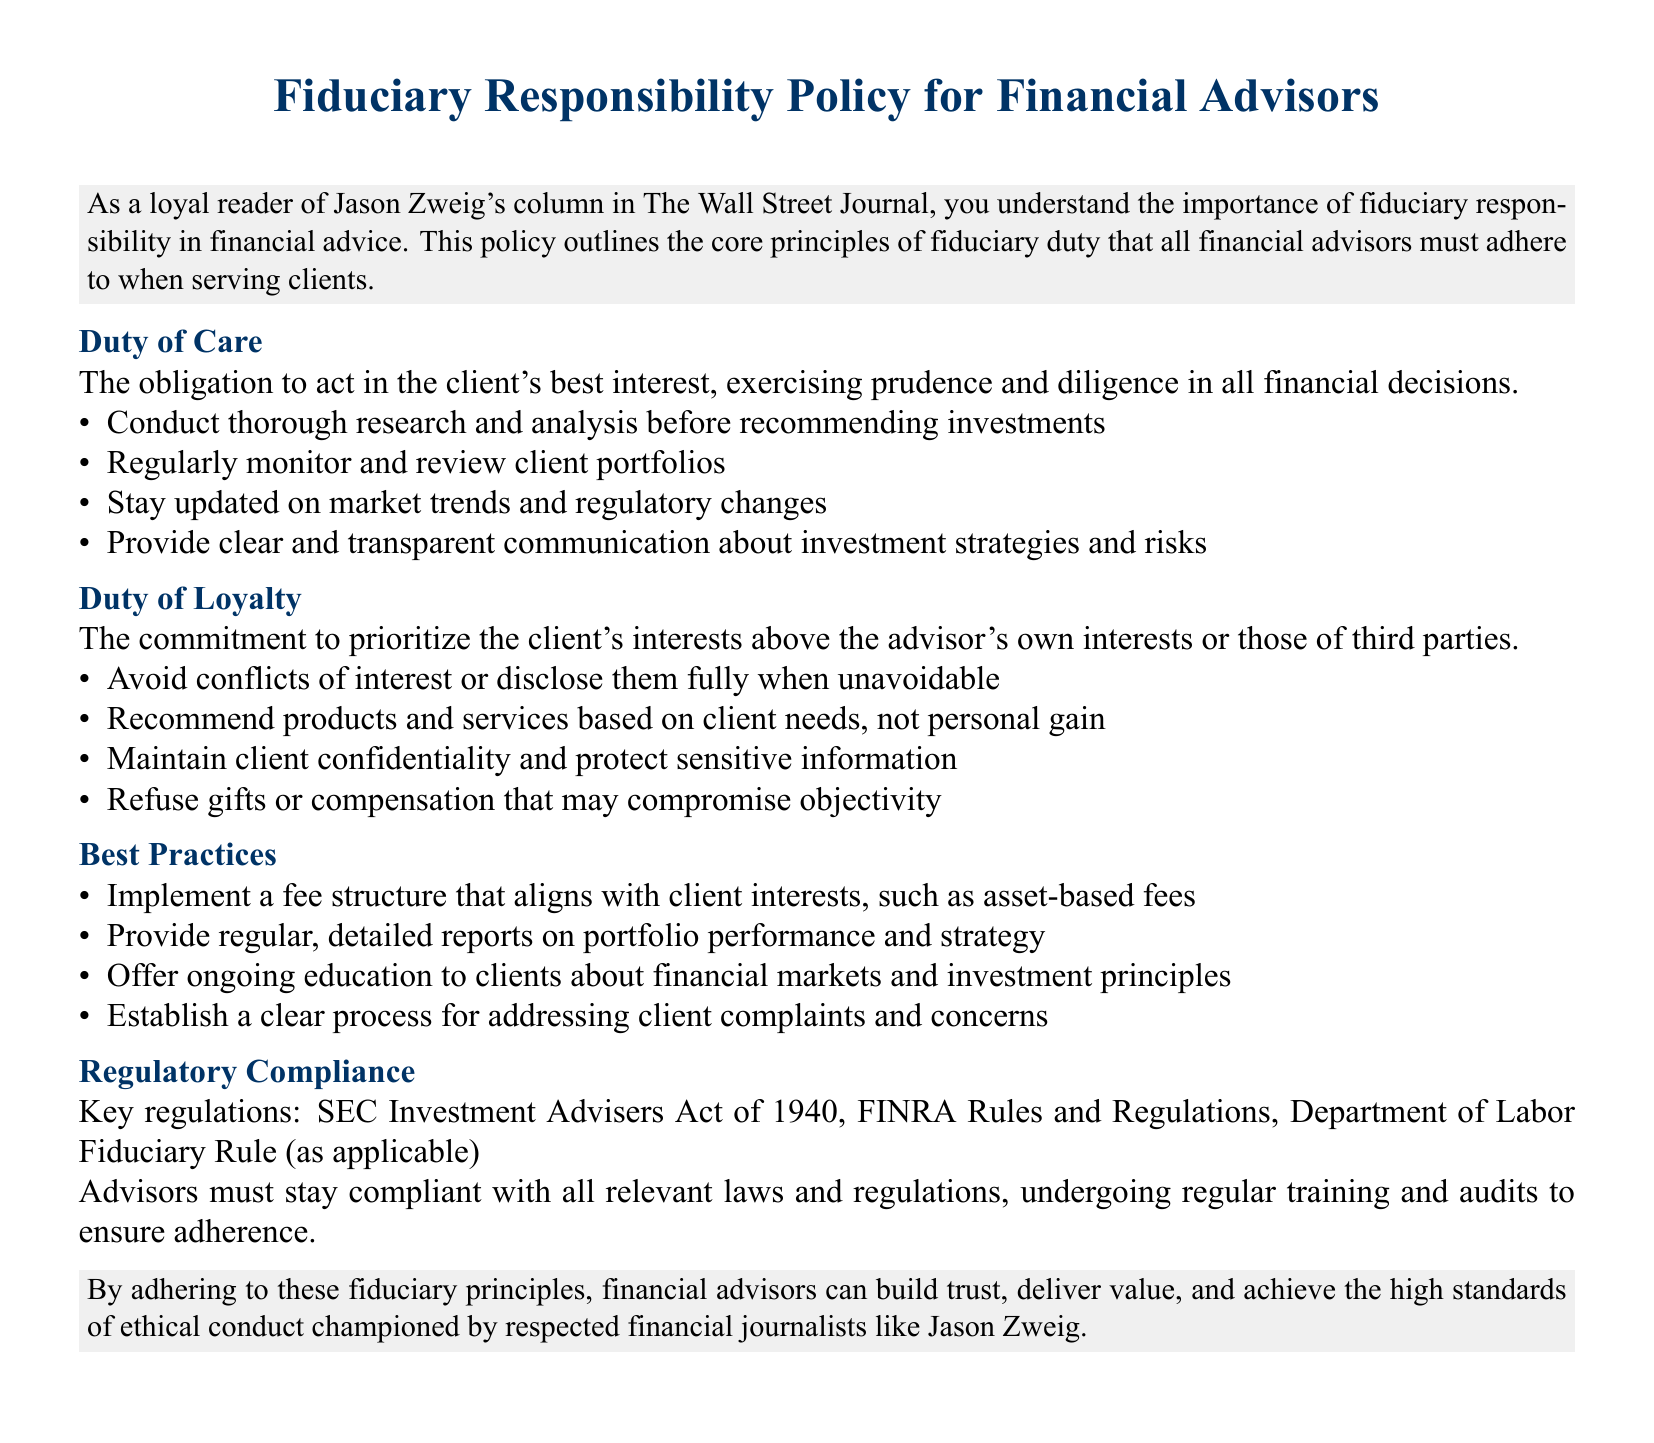What is the primary obligation of financial advisors? The primary obligation is to act in the client's best interest, exercising prudence and diligence in all financial decisions.
Answer: client's best interest What regulation is mentioned in the document? The key regulation mentioned is the SEC Investment Advisers Act of 1940.
Answer: SEC Investment Advisers Act of 1940 What is one aspect of the duty of loyalty? One aspect is to avoid conflicts of interest or disclose them fully when unavoidable.
Answer: avoid conflicts of interest How often should advisors monitor client portfolios? Advisors should regularly monitor client portfolios.
Answer: regularly What should advisors provide to clients regarding investment strategies? Advisors should provide clear and transparent communication about investment strategies and risks.
Answer: clear and transparent communication What aligns with client interests in fee structure? Implementing a fee structure that aligns with client interests, such as asset-based fees.
Answer: asset-based fees What is a best practice mentioned for addressing client issues? Establishing a clear process for addressing client complaints and concerns.
Answer: clear process Which duty entails exercising diligence in decisions? The duty of care entails exercising diligence in decisions.
Answer: duty of care What should advisors maintain concerning client information? Advisors should maintain client confidentiality and protect sensitive information.
Answer: client confidentiality 